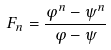Convert formula to latex. <formula><loc_0><loc_0><loc_500><loc_500>F _ { n } = \frac { \varphi ^ { n } - \psi ^ { n } } { \varphi - \psi }</formula> 